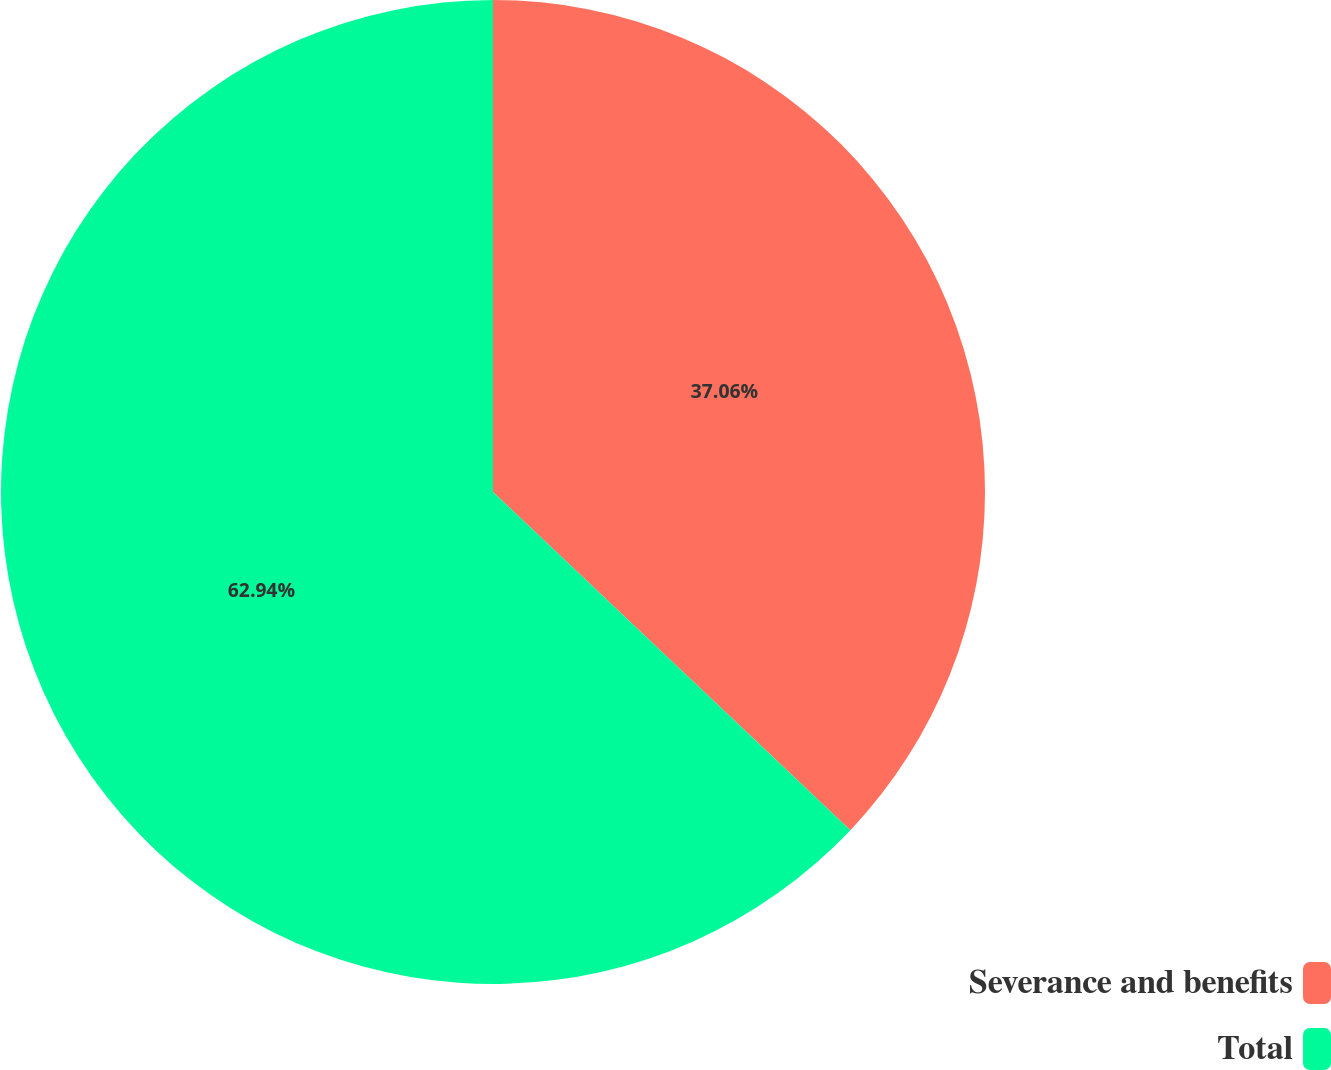<chart> <loc_0><loc_0><loc_500><loc_500><pie_chart><fcel>Severance and benefits<fcel>Total<nl><fcel>37.06%<fcel>62.94%<nl></chart> 